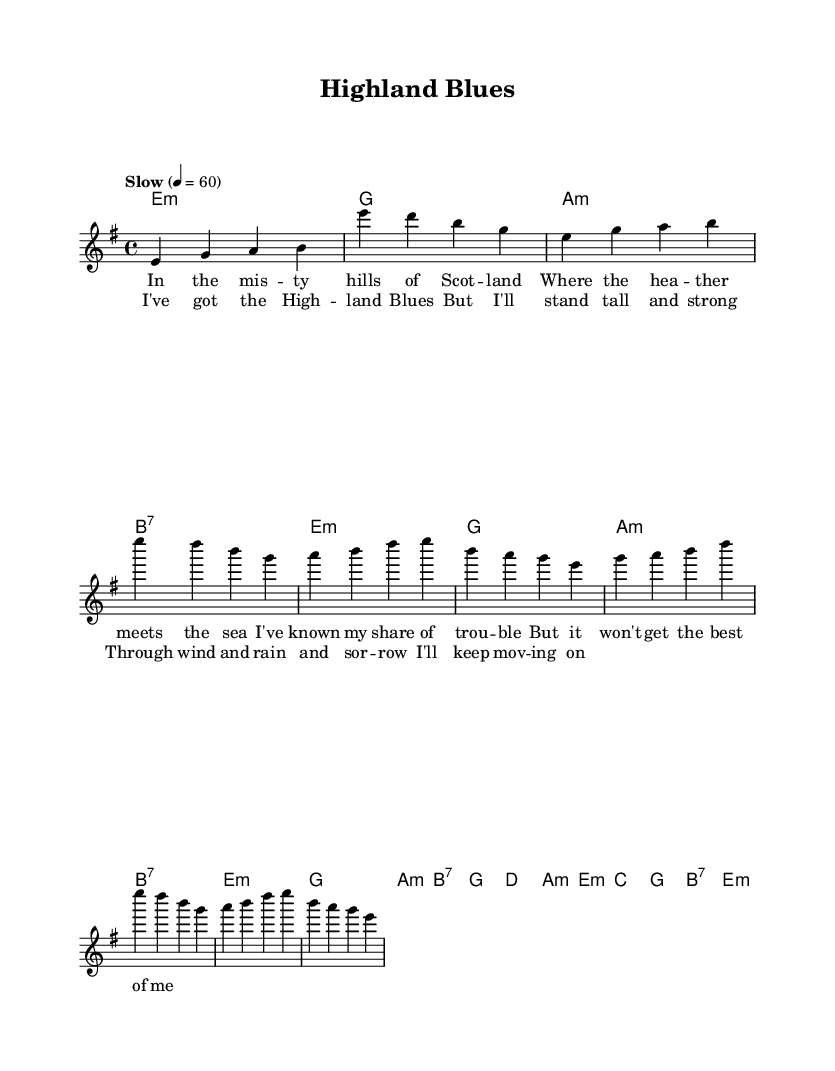What is the key signature of this music? The key signature is E minor, which has one sharp (F#). This can be determined by looking at the key indicated in the global variable section of the code.
Answer: E minor What is the time signature of this music? The time signature is 4/4, which allows four beats per measure. This is noted in the global variable section where it is set as \time 4/4.
Answer: 4/4 What is the tempo marking for this piece? The tempo marking is "Slow," with a speed of 60 beats per minute. This is indicated in the global variable section where tempo is specified.
Answer: Slow How many measures are in the chorus section? The chorus has four measures; this can be counted directly from the melody and harmonies where the chorus is defined.
Answer: 4 What is the primary theme of the lyrics? The primary theme of the lyrics is resilience in the face of hardship, expressed through lines about enduring troubles and remaining strong. This theme is apparent in both the verse and chorus sections of the lyrics.
Answer: Resilience What chord is used in the intro? The first chord in the intro is E minor, as seen in the harmonies section where the intro chords are defined.
Answer: E minor How many distinct chords are used in the entire piece? There are seven distinct chords: E minor, G, A minor, B7, D, C, and this can be identified by reviewing the chord progression laid out in the harmonies section.
Answer: 7 